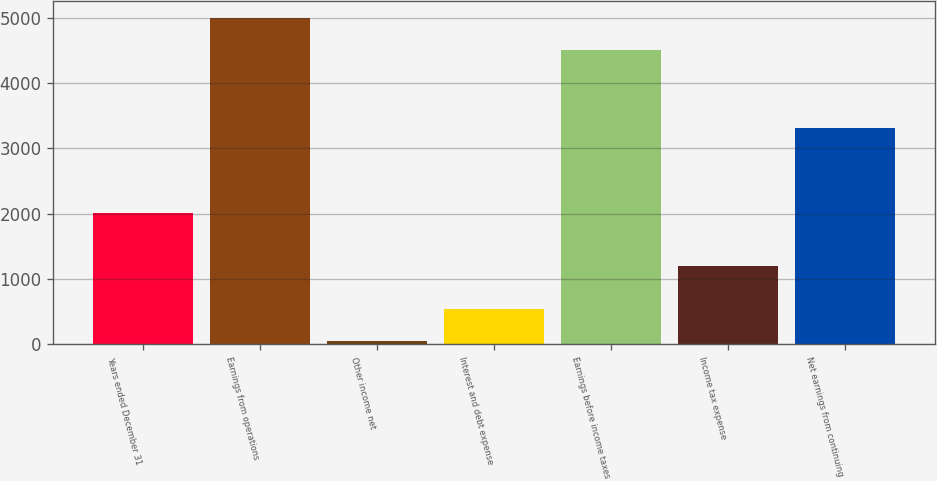Convert chart to OTSL. <chart><loc_0><loc_0><loc_500><loc_500><bar_chart><fcel>Years ended December 31<fcel>Earnings from operations<fcel>Other income net<fcel>Interest and debt expense<fcel>Earnings before income taxes<fcel>Income tax expense<fcel>Net earnings from continuing<nl><fcel>2010<fcel>4998.9<fcel>52<fcel>543.9<fcel>4507<fcel>1196<fcel>3311<nl></chart> 